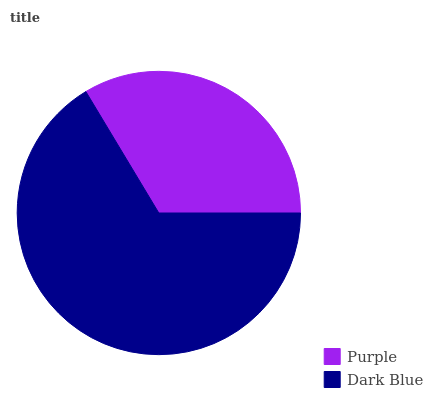Is Purple the minimum?
Answer yes or no. Yes. Is Dark Blue the maximum?
Answer yes or no. Yes. Is Dark Blue the minimum?
Answer yes or no. No. Is Dark Blue greater than Purple?
Answer yes or no. Yes. Is Purple less than Dark Blue?
Answer yes or no. Yes. Is Purple greater than Dark Blue?
Answer yes or no. No. Is Dark Blue less than Purple?
Answer yes or no. No. Is Dark Blue the high median?
Answer yes or no. Yes. Is Purple the low median?
Answer yes or no. Yes. Is Purple the high median?
Answer yes or no. No. Is Dark Blue the low median?
Answer yes or no. No. 